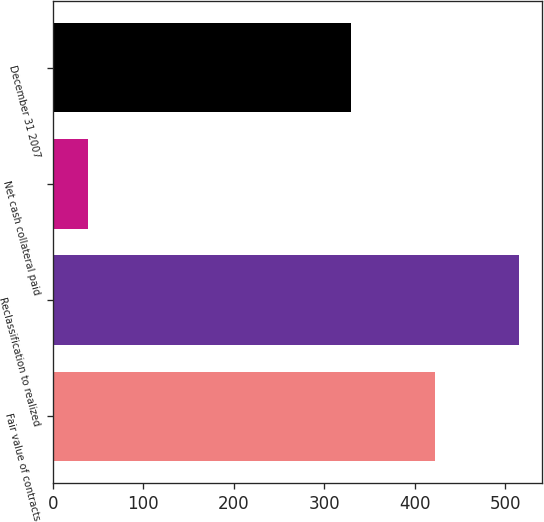Convert chart to OTSL. <chart><loc_0><loc_0><loc_500><loc_500><bar_chart><fcel>Fair value of contracts<fcel>Reclassification to realized<fcel>Net cash collateral paid<fcel>December 31 2007<nl><fcel>422.5<fcel>515<fcel>39<fcel>330<nl></chart> 